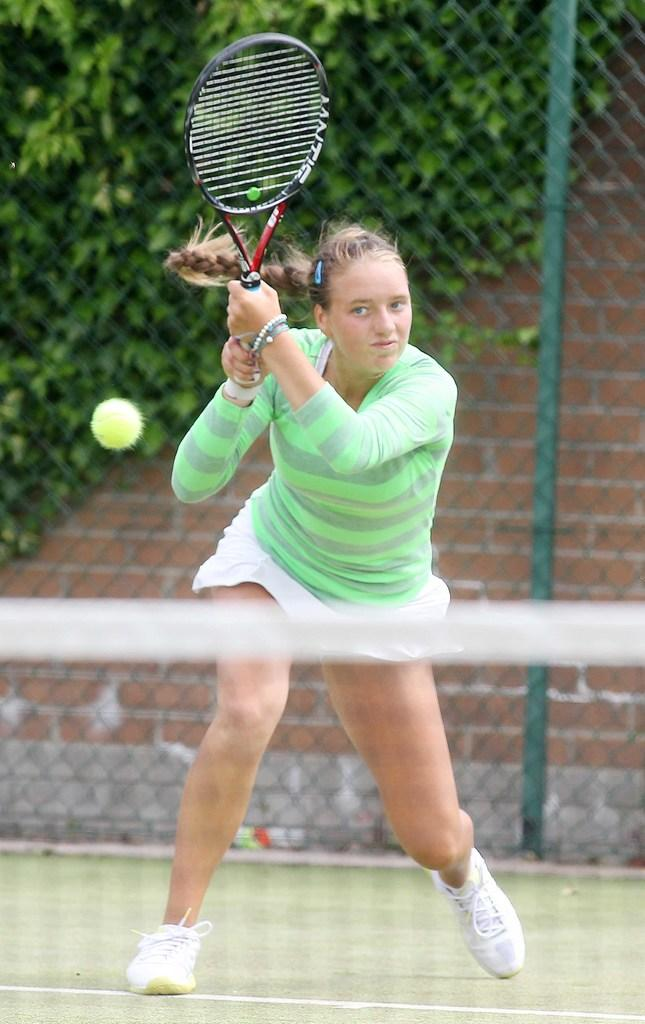Who is the main subject in the image? There is a woman in the image. What is the woman doing in the image? The woman is playing tennis. What is the background of the image made of? There is a mesh behind the woman. What can be seen beyond the mesh? There are trees visible behind the mesh. Can you tell me how many ducks are visible on the woman's wrist in the image? There are no ducks visible on the woman's wrist in the image. What sense is being used by the woman while playing tennis in the image? The question about the sense being used by the woman is not directly answerable from the provided facts, as it does not mention any specific sensory activity. 